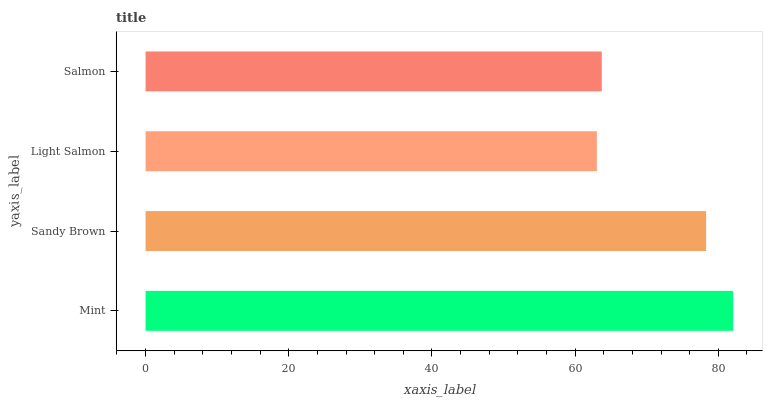Is Light Salmon the minimum?
Answer yes or no. Yes. Is Mint the maximum?
Answer yes or no. Yes. Is Sandy Brown the minimum?
Answer yes or no. No. Is Sandy Brown the maximum?
Answer yes or no. No. Is Mint greater than Sandy Brown?
Answer yes or no. Yes. Is Sandy Brown less than Mint?
Answer yes or no. Yes. Is Sandy Brown greater than Mint?
Answer yes or no. No. Is Mint less than Sandy Brown?
Answer yes or no. No. Is Sandy Brown the high median?
Answer yes or no. Yes. Is Salmon the low median?
Answer yes or no. Yes. Is Mint the high median?
Answer yes or no. No. Is Sandy Brown the low median?
Answer yes or no. No. 